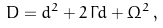<formula> <loc_0><loc_0><loc_500><loc_500>D = d ^ { 2 } + 2 \, \Gamma d + \Omega ^ { 2 } \, ,</formula> 